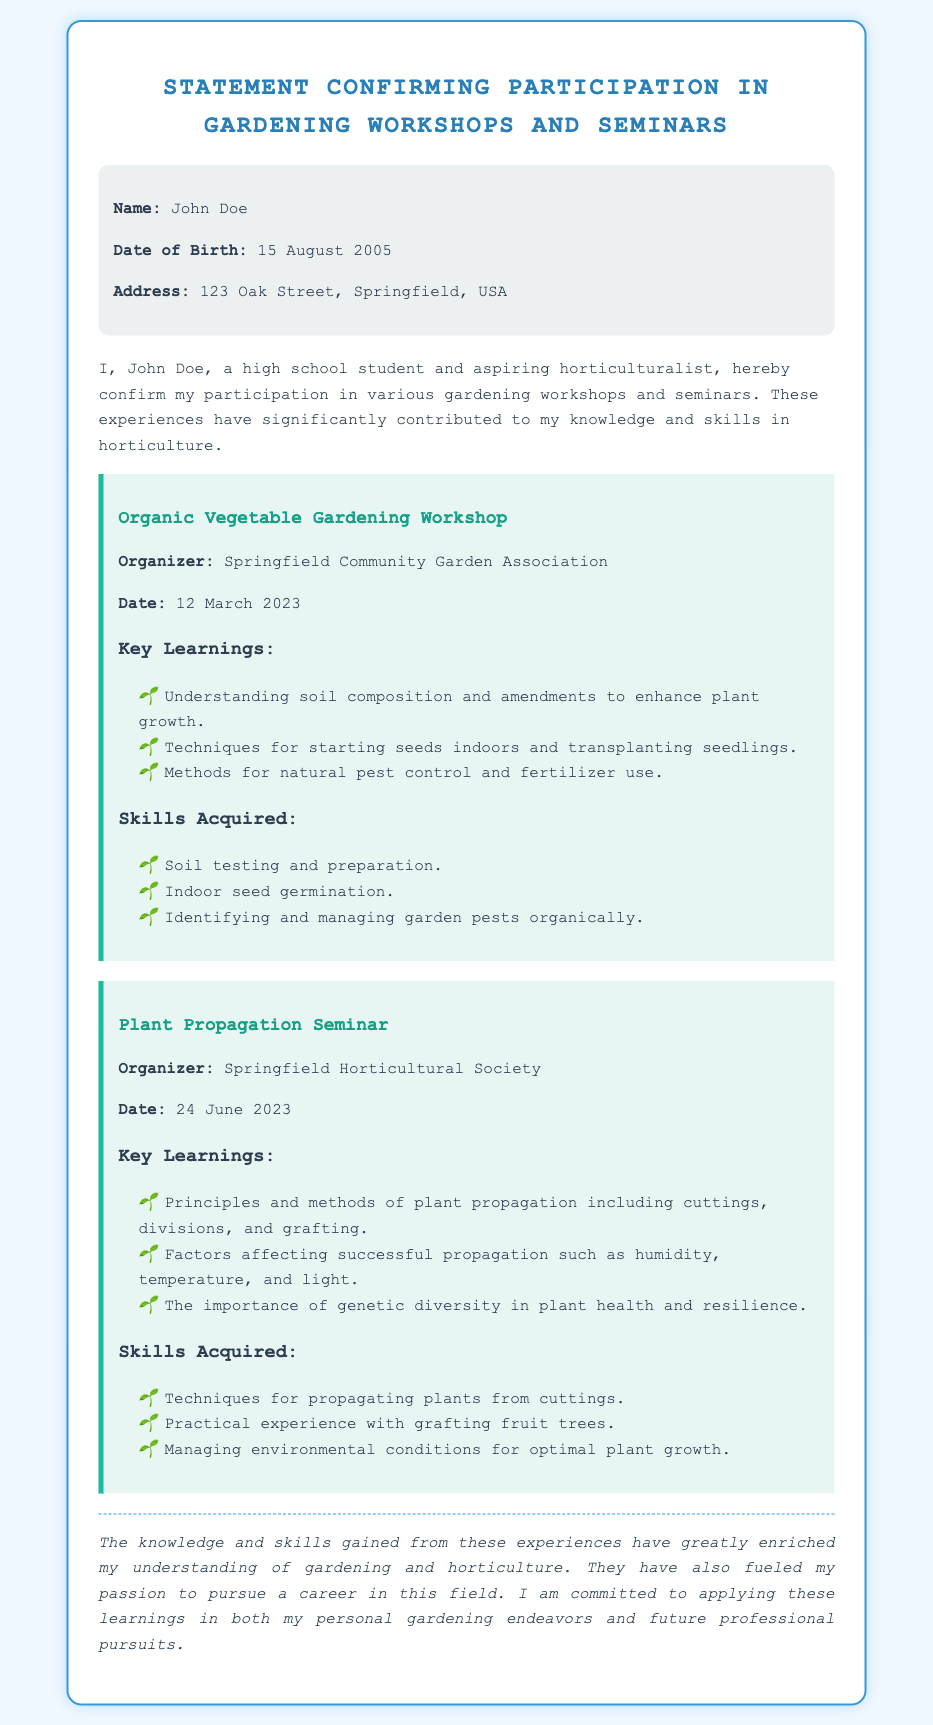what is the name of the participant? The name of the participant is mentioned at the beginning of the document.
Answer: John Doe what is the date of birth of the participant? The participant's date of birth is stated in the personal information section.
Answer: 15 August 2005 what is the date of the Organic Vegetable Gardening Workshop? The date of this workshop is listed under the workshop details.
Answer: 12 March 2023 who organized the Plant Propagation Seminar? The organizer's name is specified in the workshop section of the document.
Answer: Springfield Horticultural Society what is one of the key learnings from the Organic Vegetable Gardening Workshop? The key learnings are detailed in bulleted lists, one of which needs to be identified.
Answer: Understanding soil composition and amendments to enhance plant growth how many skills acquired are listed for the Plant Propagation Seminar? Counting the skills mentioned provides the answer found in the skills section related to the seminar.
Answer: Three what do the skills acquired demonstrate about the participant? The skills acquired reflect the participant's learned abilities from the workshops and seminars mentioned in the affidavit.
Answer: Practical horticultural knowledge why is the participant committed to applying their learnings? The document concludes with an expression of the participant's dedication to their gardening practice.
Answer: Pursuing a career in horticulture 